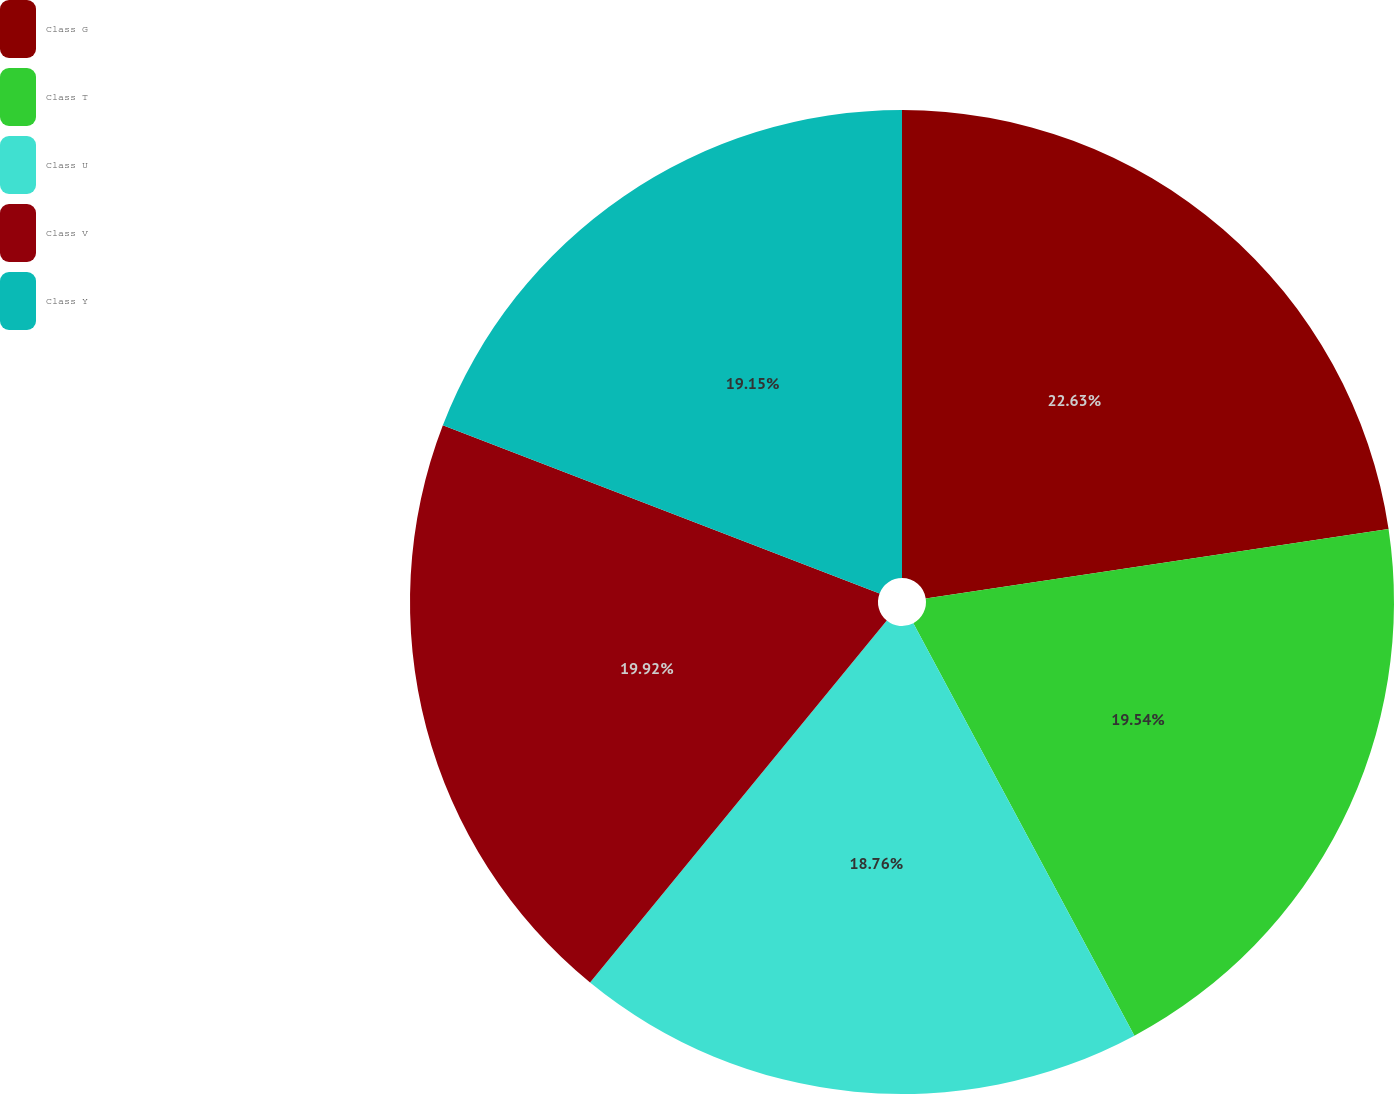<chart> <loc_0><loc_0><loc_500><loc_500><pie_chart><fcel>Class G<fcel>Class T<fcel>Class U<fcel>Class V<fcel>Class Y<nl><fcel>22.63%<fcel>19.54%<fcel>18.76%<fcel>19.92%<fcel>19.15%<nl></chart> 